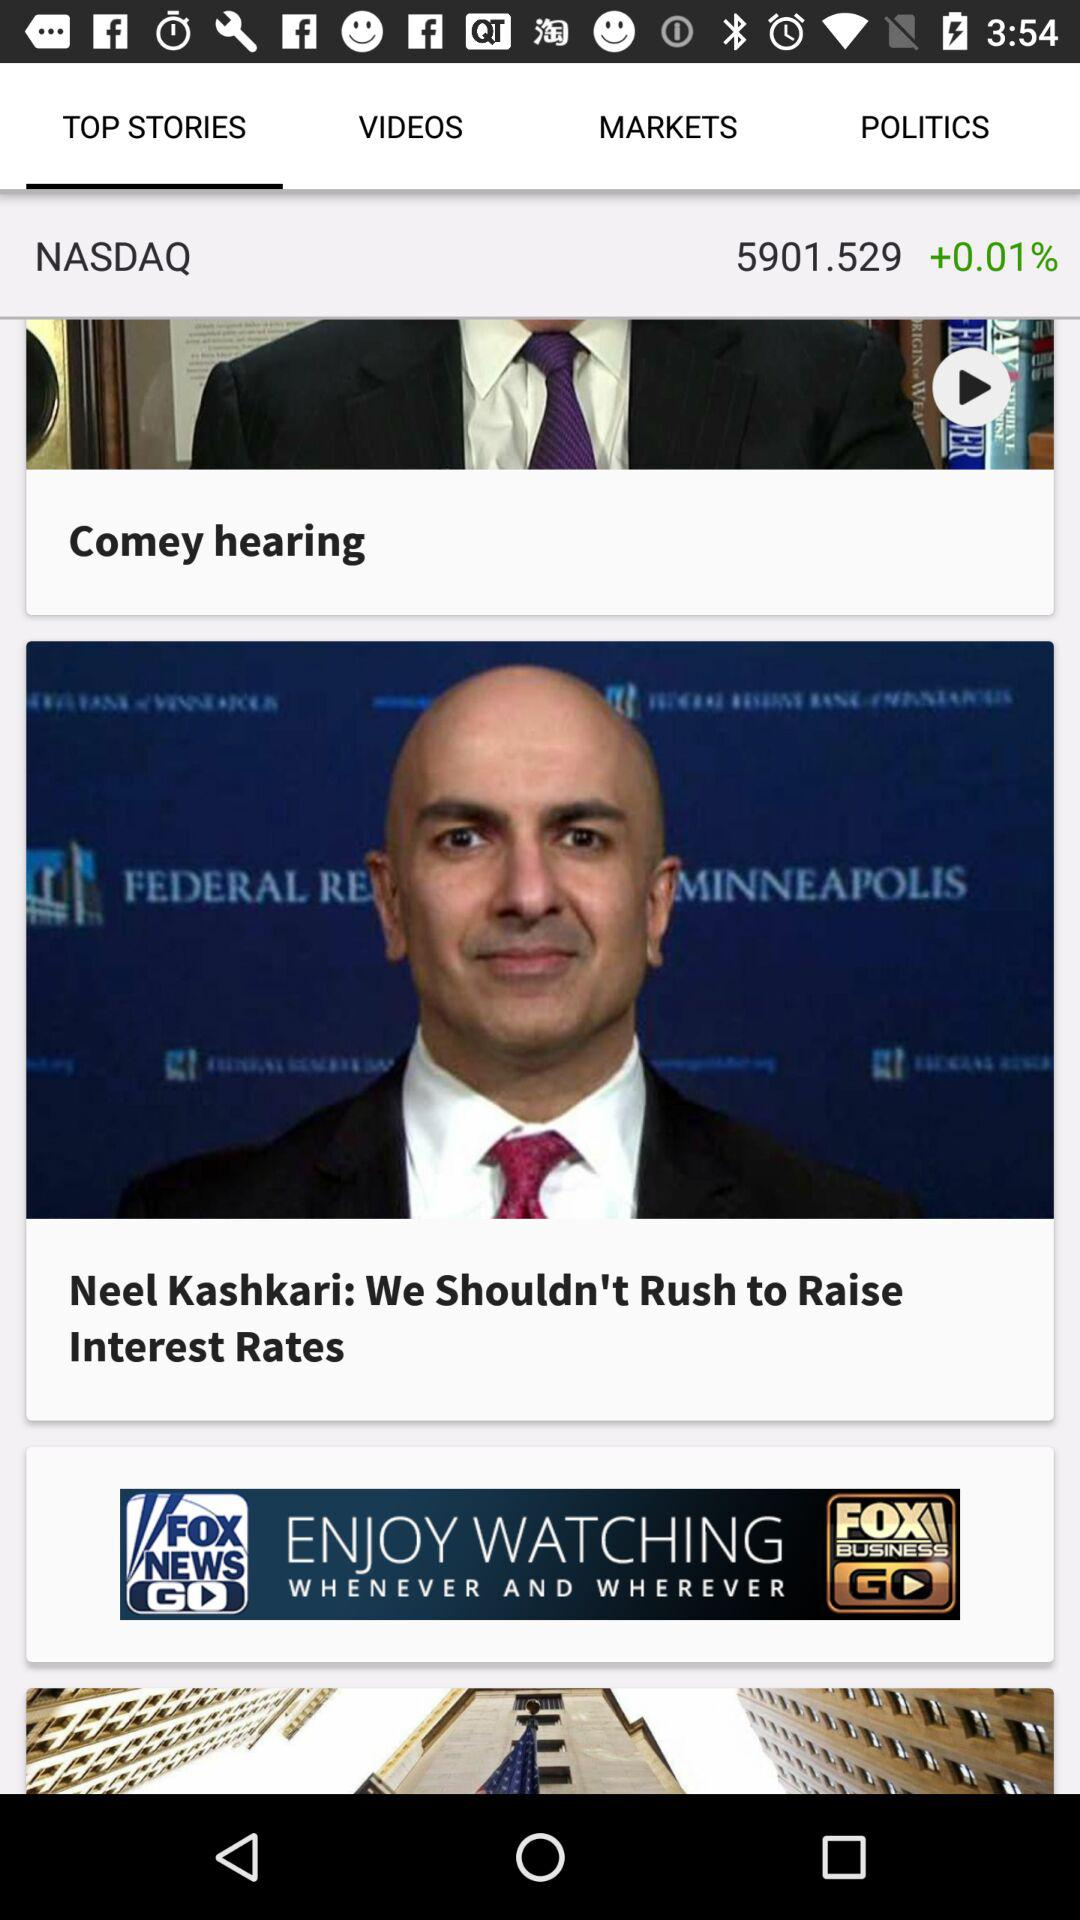What is the percentage change in the NASDAQ index since the last update?
Answer the question using a single word or phrase. +0.01% 